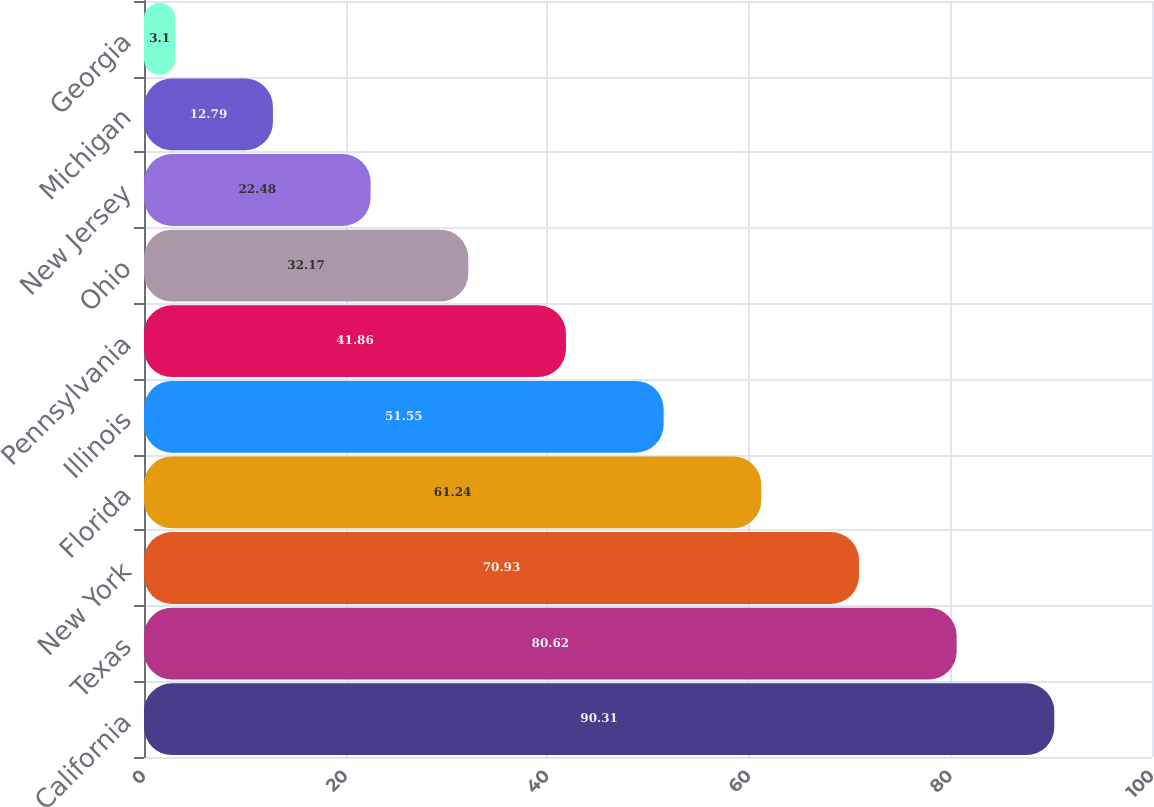<chart> <loc_0><loc_0><loc_500><loc_500><bar_chart><fcel>California<fcel>Texas<fcel>New York<fcel>Florida<fcel>Illinois<fcel>Pennsylvania<fcel>Ohio<fcel>New Jersey<fcel>Michigan<fcel>Georgia<nl><fcel>90.31<fcel>80.62<fcel>70.93<fcel>61.24<fcel>51.55<fcel>41.86<fcel>32.17<fcel>22.48<fcel>12.79<fcel>3.1<nl></chart> 